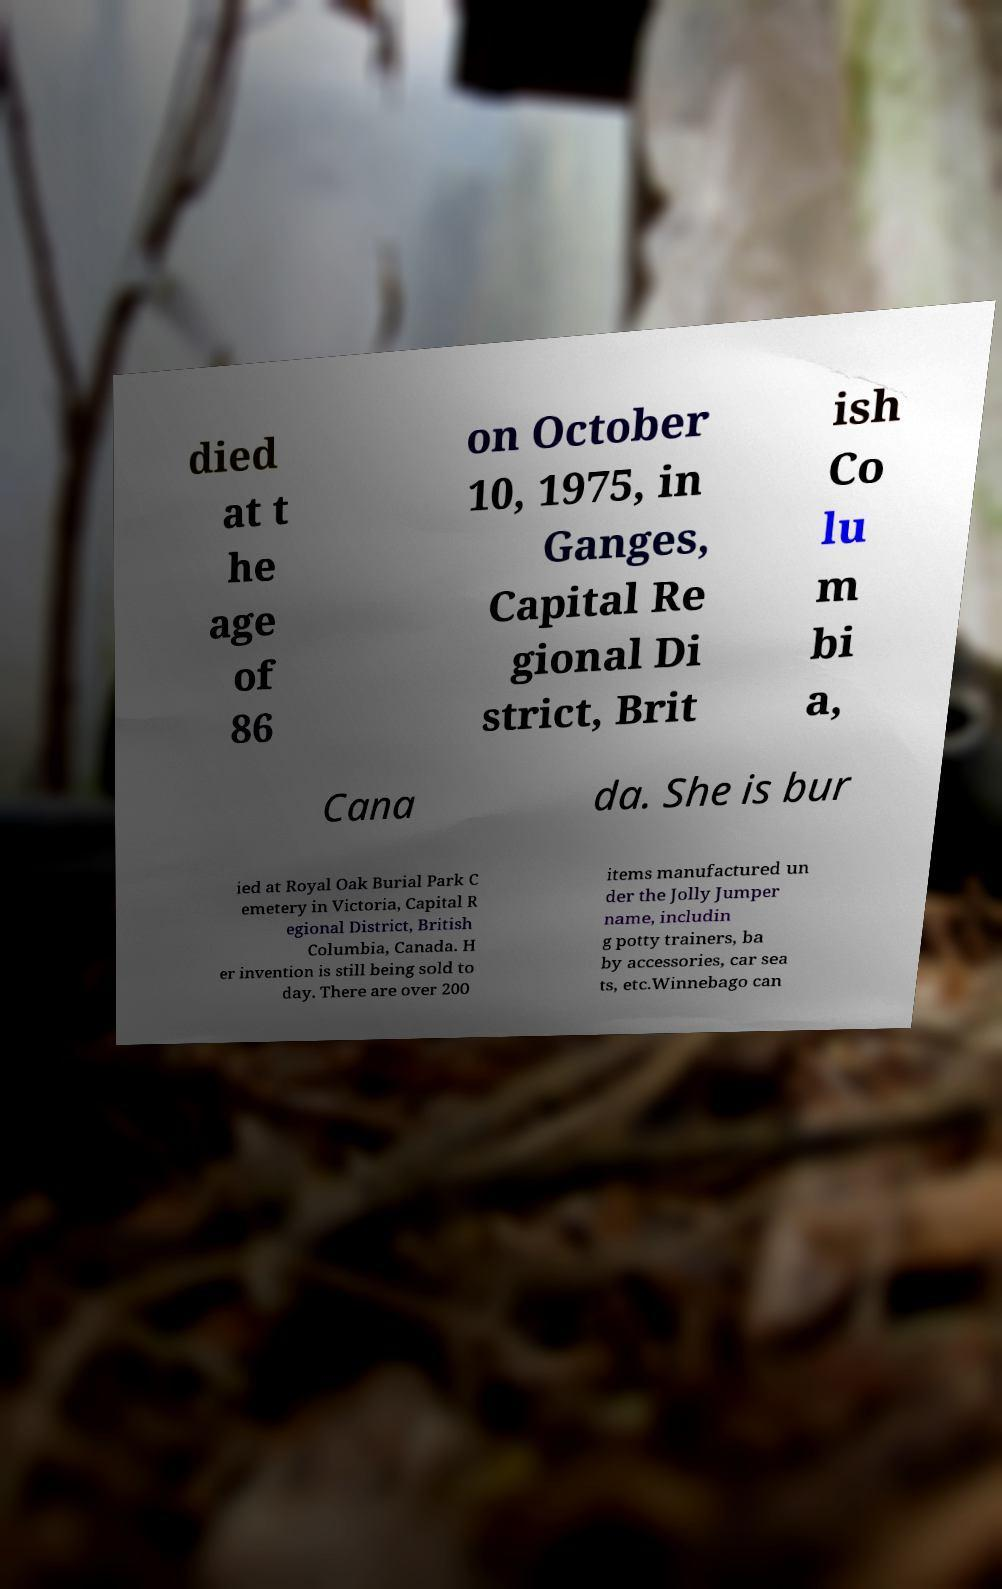Can you accurately transcribe the text from the provided image for me? died at t he age of 86 on October 10, 1975, in Ganges, Capital Re gional Di strict, Brit ish Co lu m bi a, Cana da. She is bur ied at Royal Oak Burial Park C emetery in Victoria, Capital R egional District, British Columbia, Canada. H er invention is still being sold to day. There are over 200 items manufactured un der the Jolly Jumper name, includin g potty trainers, ba by accessories, car sea ts, etc.Winnebago can 